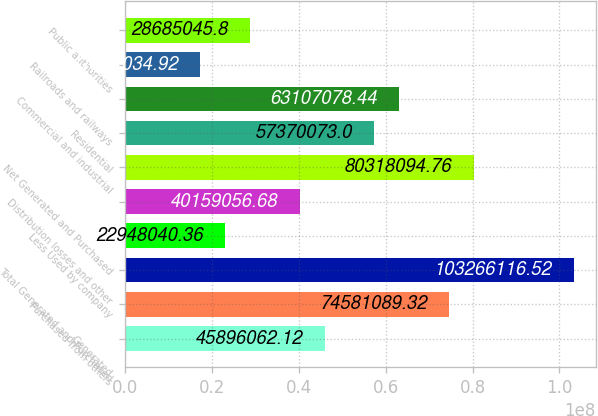Convert chart. <chart><loc_0><loc_0><loc_500><loc_500><bar_chart><fcel>Generated<fcel>Purchased from others<fcel>Total Generated and Purchased<fcel>Less Used by company<fcel>Distribution losses and other<fcel>Net Generated and Purchased<fcel>Residential<fcel>Commercial and industrial<fcel>Railroads and railways<fcel>Public authorities<nl><fcel>4.58961e+07<fcel>7.45811e+07<fcel>1.03266e+08<fcel>2.2948e+07<fcel>4.01591e+07<fcel>8.03181e+07<fcel>5.73701e+07<fcel>6.31071e+07<fcel>1.7211e+07<fcel>2.8685e+07<nl></chart> 